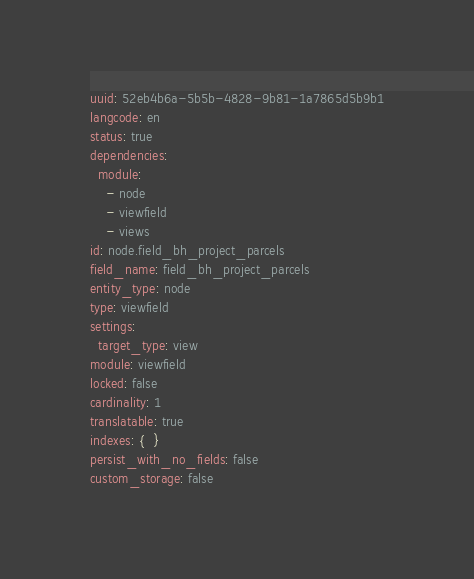<code> <loc_0><loc_0><loc_500><loc_500><_YAML_>uuid: 52eb4b6a-5b5b-4828-9b81-1a7865d5b9b1
langcode: en
status: true
dependencies:
  module:
    - node
    - viewfield
    - views
id: node.field_bh_project_parcels
field_name: field_bh_project_parcels
entity_type: node
type: viewfield
settings:
  target_type: view
module: viewfield
locked: false
cardinality: 1
translatable: true
indexes: {  }
persist_with_no_fields: false
custom_storage: false
</code> 